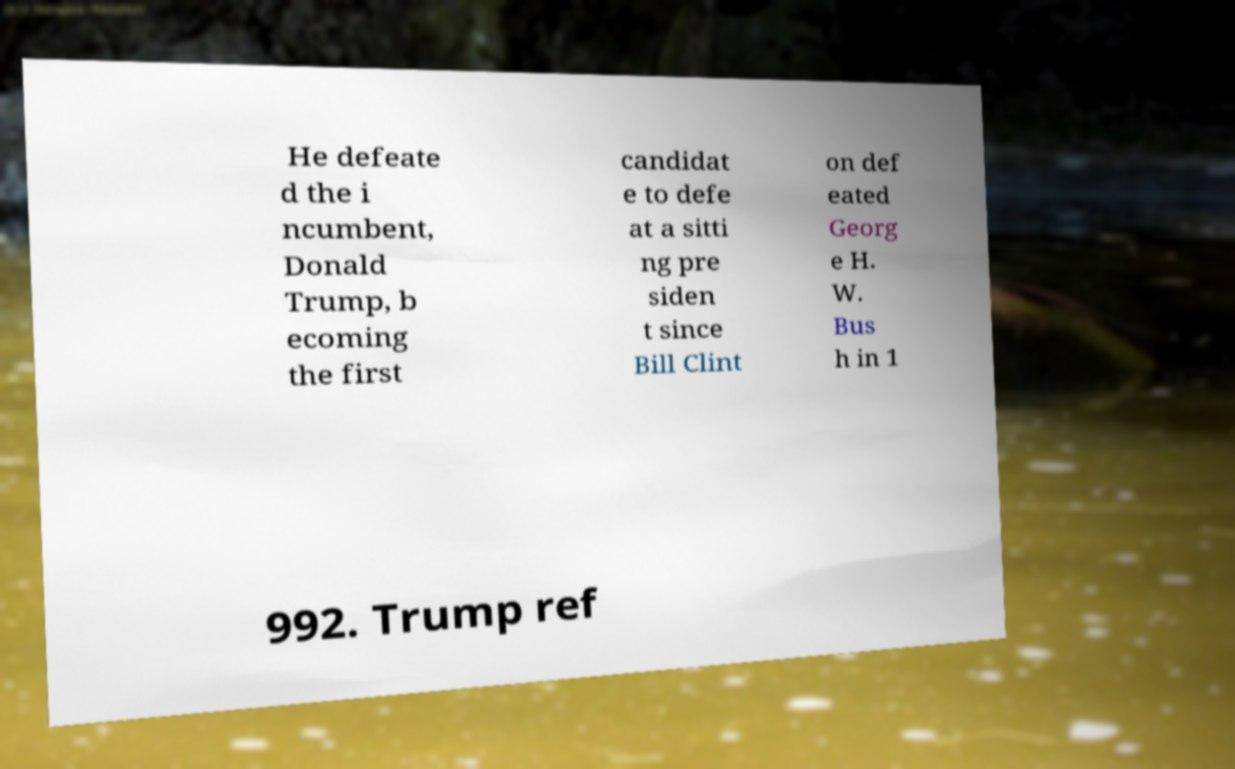Please read and relay the text visible in this image. What does it say? He defeate d the i ncumbent, Donald Trump, b ecoming the first candidat e to defe at a sitti ng pre siden t since Bill Clint on def eated Georg e H. W. Bus h in 1 992. Trump ref 